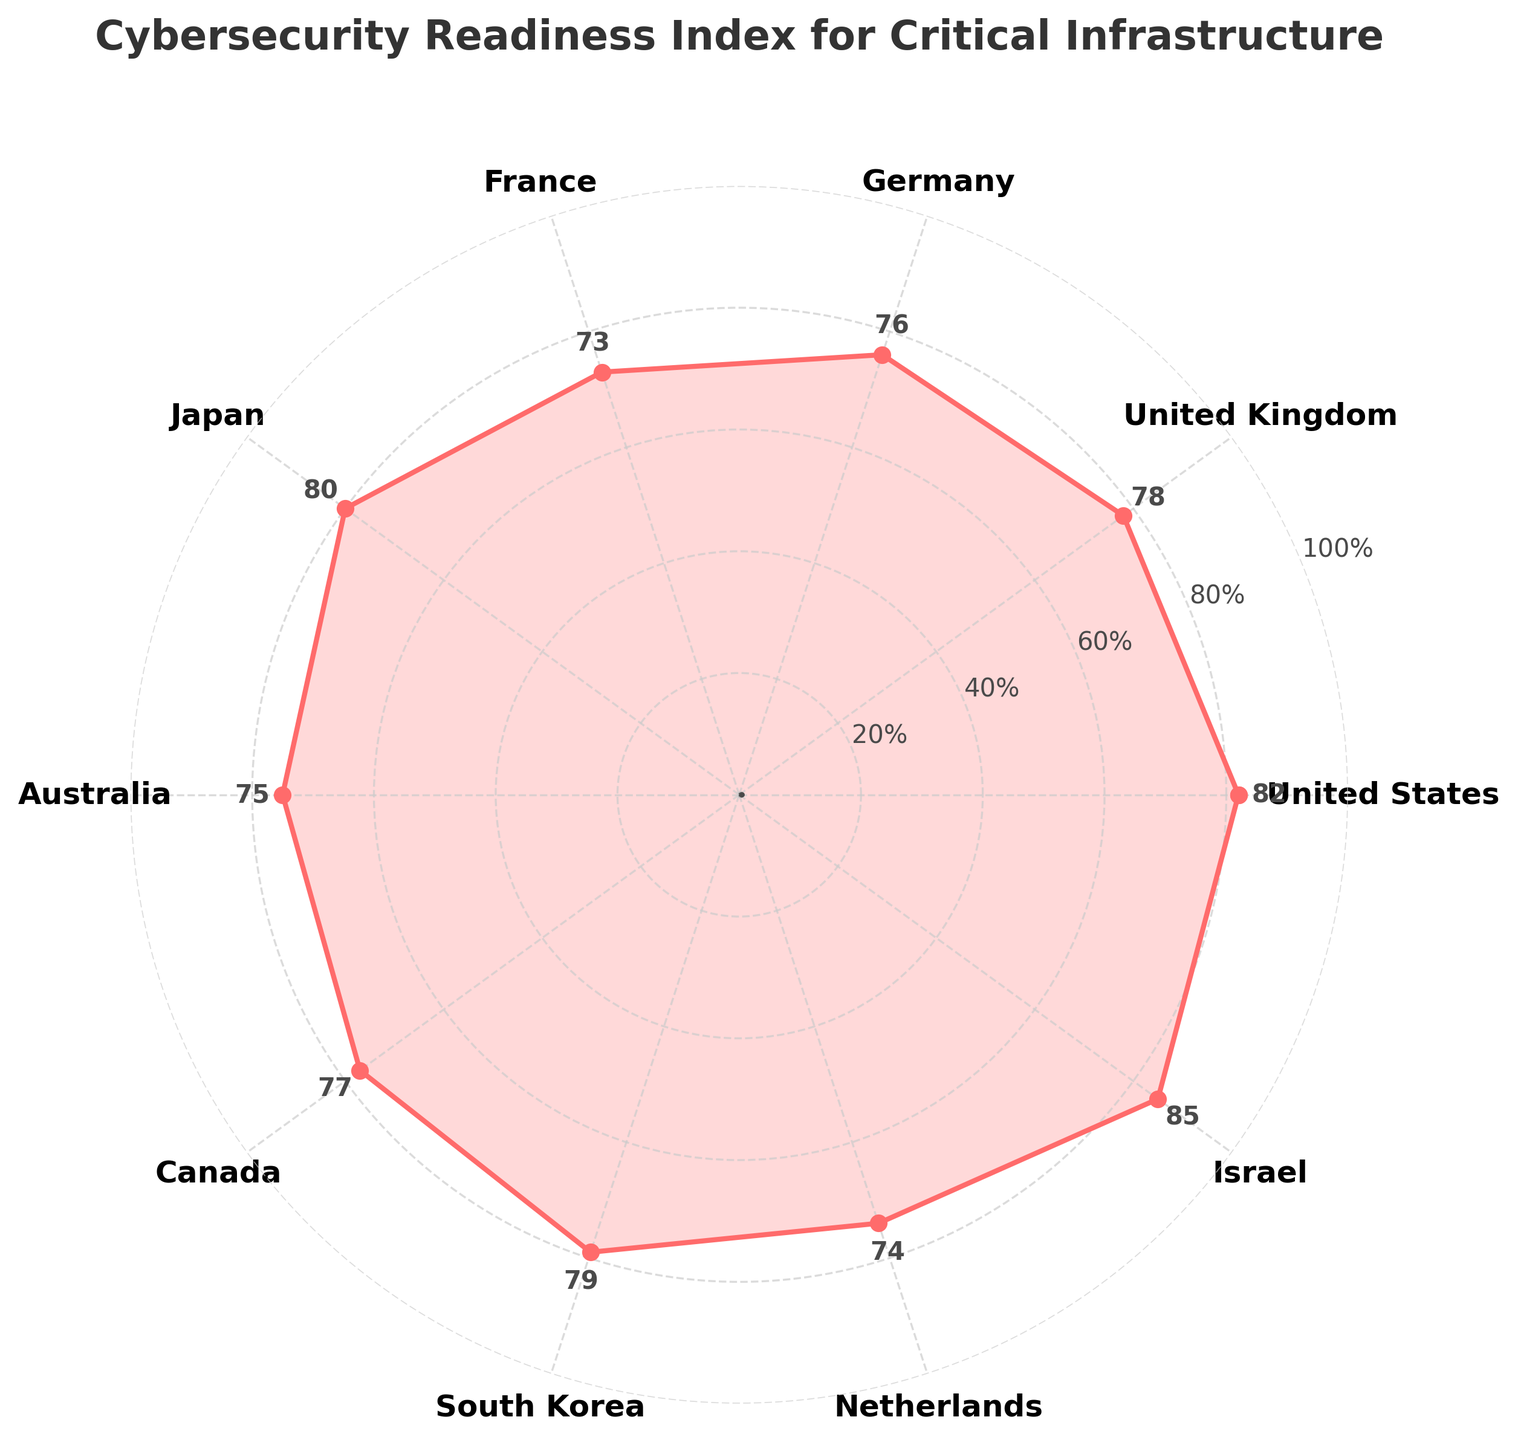What is the title of the figure? The title is displayed at the top of the figure.
Answer: Cybersecurity Readiness Index for Critical Infrastructure Which country has the highest readiness index? The country with the highest marked value is Israel, which is positioned at 85 on the index.
Answer: Israel Which country has the lowest readiness index? The country with the lowest marked value is France, which is positioned at 73 on the index.
Answer: France What is the readiness index of the United States? The readiness index of the United States is marked where the United States label aligns on the gauge plot, which is 82.
Answer: 82 How many countries have a readiness index above 80? By counting the countries with values above 80, we see United States, Japan, South Korea, and Israel.
Answer: 4 What is the average readiness index of the countries shown? Sum all indices (82 + 78 + 76 + 73 + 80 + 75 + 77 + 79 + 74 + 85) = 779 and divide by the number of countries, which is 10. So the average is 779/10 = 77.9
Answer: 77.9 Which countries have a readiness index between 75 and 80? The countries whose indices fall within this range are Germany (76), Australia (75), and Canada (77).
Answer: Germany, Australia, Canada How does the readiness index of Japan compare to Germany? Japan's readiness index is 80, while Germany's is 76. Therefore, Japan's index is higher by 4 points.
Answer: Japan's index is higher by 4 points What is the gap between the highest and the lowest readiness indices? The highest readiness index is 85 (Israel) and the lowest is 73 (France). Subtracting these values gives us 85 - 73 = 12.
Answer: 12 What is the median readiness index of the listed countries? Sorting the indices: [73, 74, 75, 76, 77, 78, 79, 80, 82, 85], the median is the average of the 5th (77) and 6th (78) values: (77+78)/2 = 77.5
Answer: 77.5 